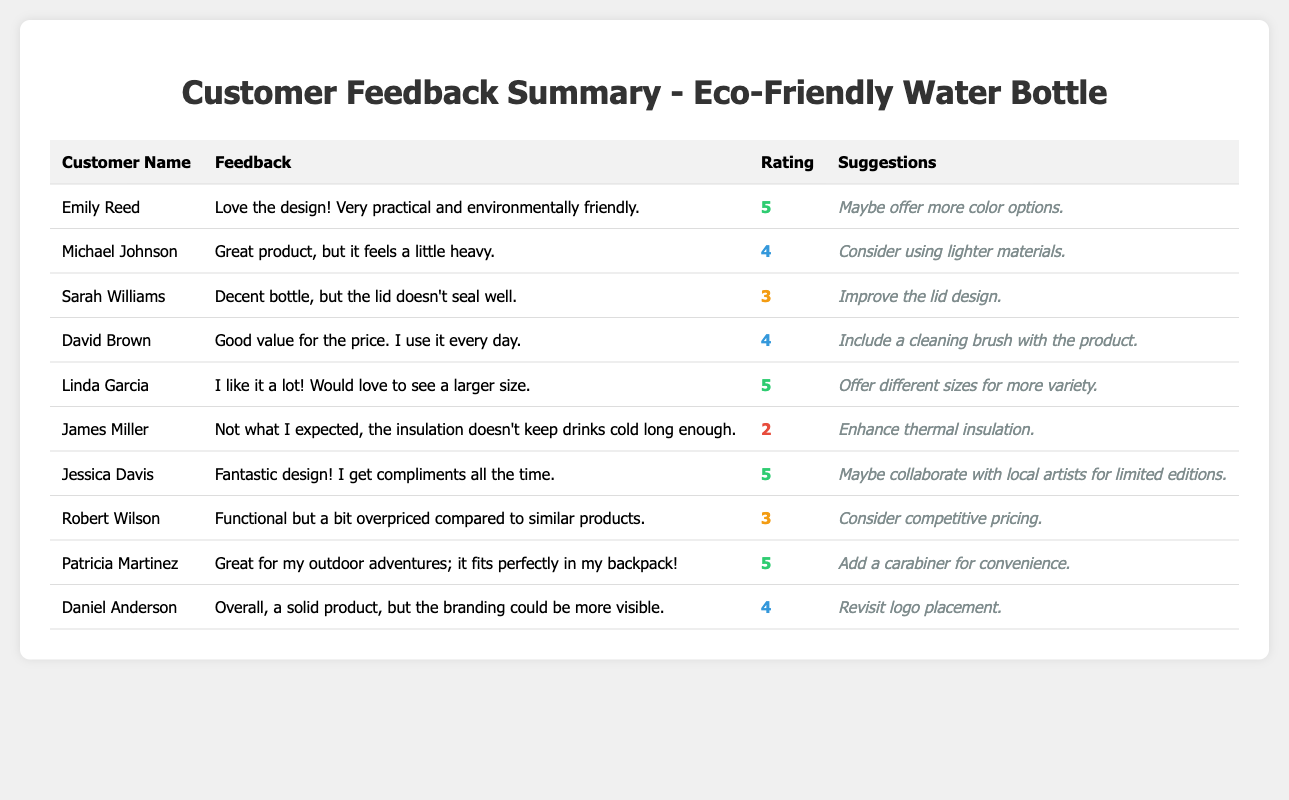What is the highest rating received for the product? The highest rating in the table is a 5. It is given by Emily Reed, Linda Garcia, and Jessica Davis.
Answer: 5 How many customers rated the product 4 stars? There are 4 customers who rated the product 4 stars: Michael Johnson, David Brown, Daniel Anderson, and Jessica Davis.
Answer: 4 What suggestions did the customer with the lowest rating provide? James Miller received the lowest rating of 2 stars and suggested enhancing thermal insulation.
Answer: Enhance thermal insulation What is the average rating of the feedback received? The ratings are 5, 4, 3, 4, 5, 2, 5, 3, 5, and 4. The total is (5 + 4 + 3 + 4 + 5 + 2 + 5 + 3 + 5 + 4) = 46 and there are 10 ratings. The average is 46/10 = 4.6.
Answer: 4.6 Did any customer suggest to improve the lid design? Yes, Sarah Williams gave a feedback of 3 stars and suggested improving the lid design.
Answer: Yes Which customer suggested adding a carabiner for convenience? Patricia Martinez suggested adding a carabiner for convenience in her feedback.
Answer: Patricia Martinez What percentage of customers gave the product a rating of 5 stars? There are 3 customers who rated it 5 stars out of 10 total customers. The percentage is (3/10) * 100 = 30%.
Answer: 30% Which customer mentioned feeling that the product was overpriced? Robert Wilson expressed that the product felt a bit overpriced compared to similar products.
Answer: Robert Wilson What feedback did customers provide about the weight of the product? Michael Johnson noted that it feels a little heavy and suggested using lighter materials.
Answer: It feels a little heavy Which customer provided feedback that the insulation does not keep drinks cold long enough? James Miller provided feedback stating that the insulation does not keep drinks cold long enough and rated it 2 stars.
Answer: James Miller What was the feedback from customers who gave a rating of 5 stars? Customers who rated it 5 stars, Emily Reed, Linda Garcia, and Jessica Davis, all praised the design, practicality, and functionality of the product.
Answer: Positive feedback 